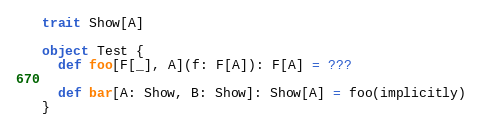Convert code to text. <code><loc_0><loc_0><loc_500><loc_500><_Scala_>trait Show[A]

object Test {
  def foo[F[_], A](f: F[A]): F[A] = ???

  def bar[A: Show, B: Show]: Show[A] = foo(implicitly) 
}
</code> 